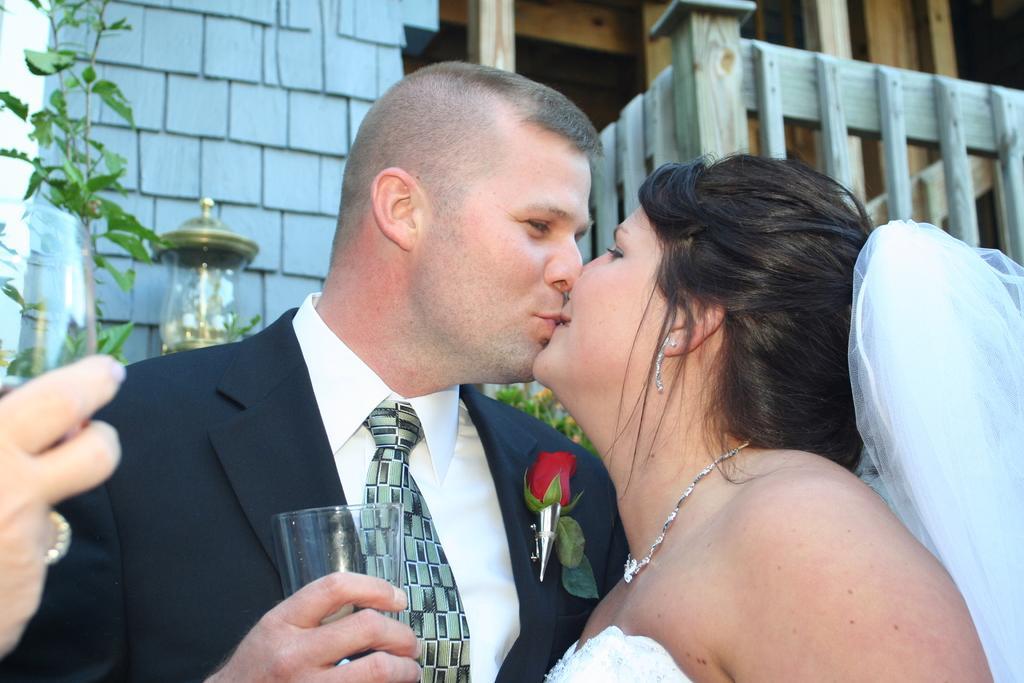Please provide a concise description of this image. In the image we can see a man and a woman wearing clothes and they are kissing each other. This is a glass, wooden fence and a lamp. 